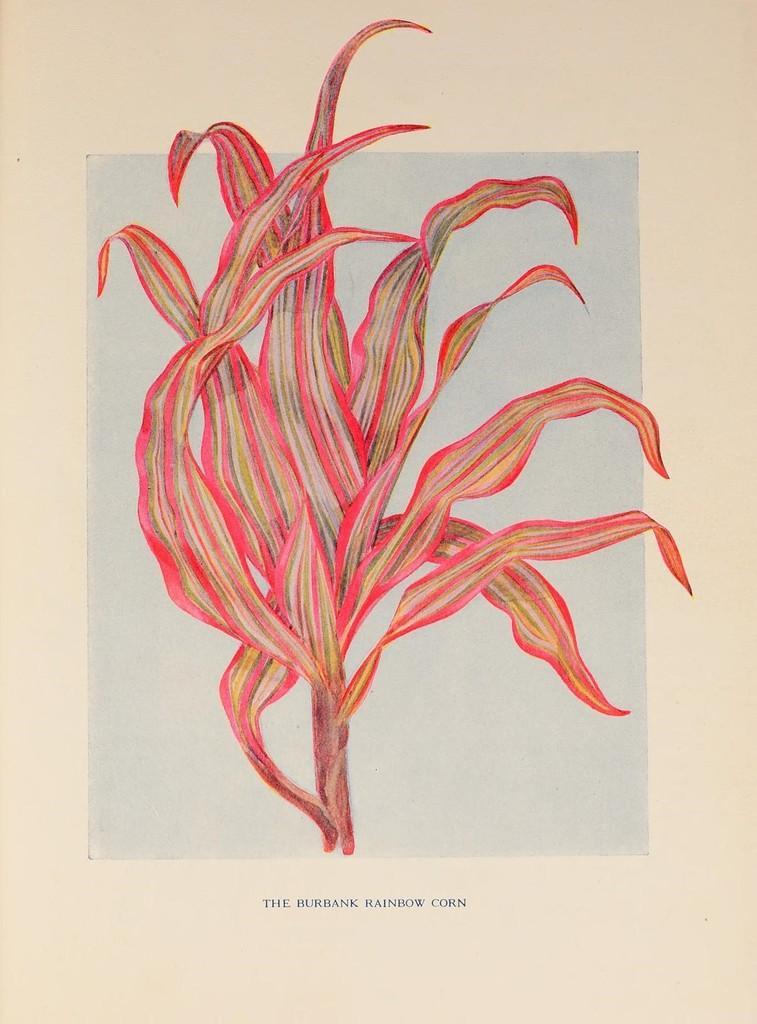Could you give a brief overview of what you see in this image? In this picture we can see a pink plant is drawn on the white paper. On the front bottom side we can see "The rainbow crown" is written. 